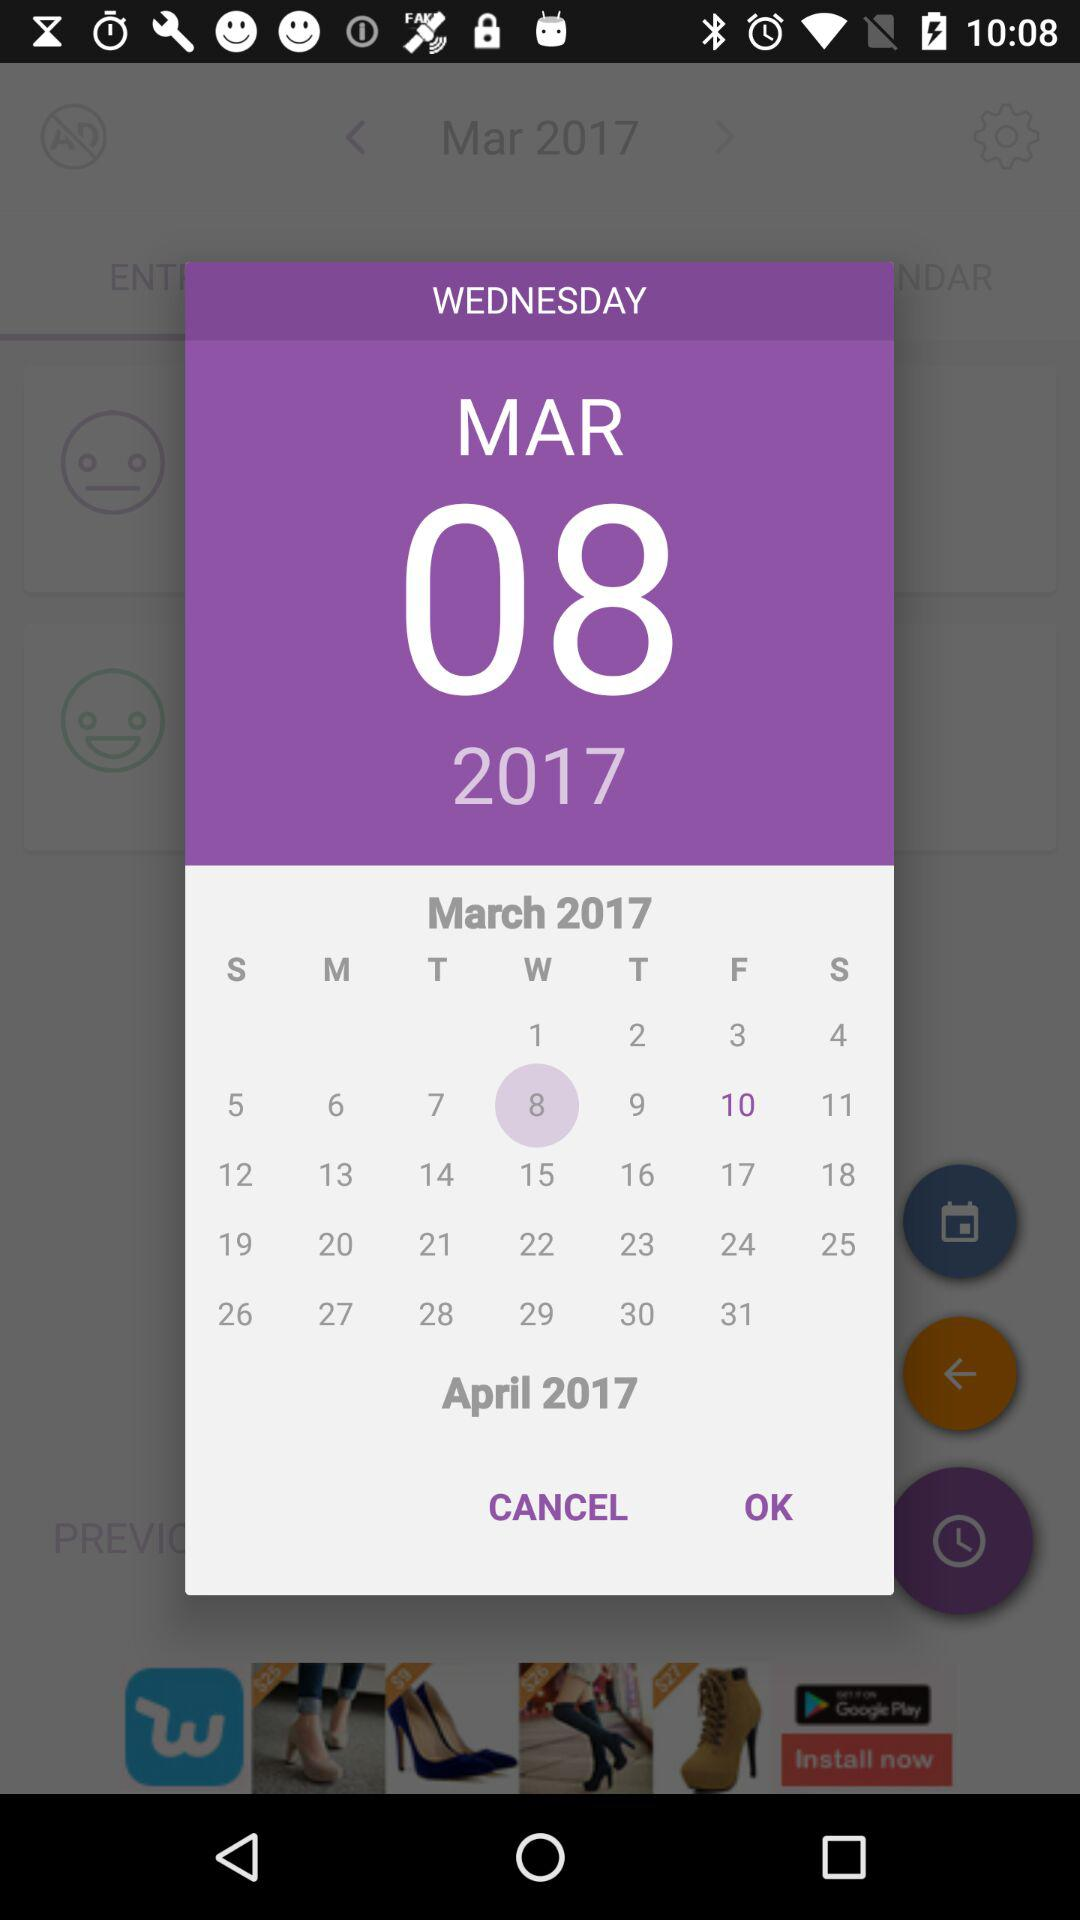What's the day on the 8th of March, 2017? The day is Wednesday. 